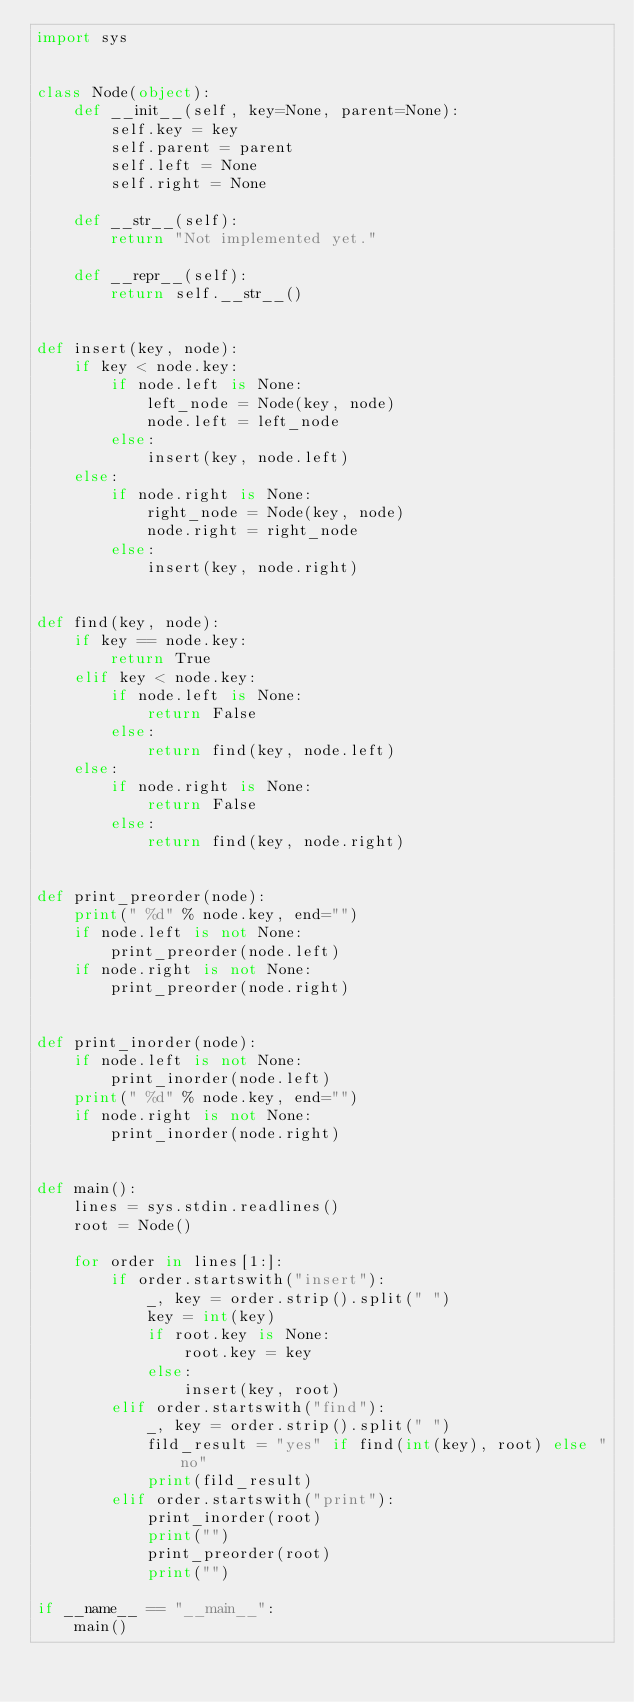Convert code to text. <code><loc_0><loc_0><loc_500><loc_500><_Python_>import sys


class Node(object):
    def __init__(self, key=None, parent=None):
        self.key = key
        self.parent = parent
        self.left = None
        self.right = None

    def __str__(self):
        return "Not implemented yet."

    def __repr__(self):
        return self.__str__()


def insert(key, node):
    if key < node.key:
        if node.left is None:
            left_node = Node(key, node)
            node.left = left_node
        else:
            insert(key, node.left)
    else:
        if node.right is None:
            right_node = Node(key, node)
            node.right = right_node
        else:
            insert(key, node.right)


def find(key, node):
    if key == node.key:
        return True
    elif key < node.key:
        if node.left is None:
            return False
        else:
            return find(key, node.left)
    else:
        if node.right is None:
            return False
        else:
            return find(key, node.right)


def print_preorder(node):
    print(" %d" % node.key, end="")
    if node.left is not None:
        print_preorder(node.left)
    if node.right is not None:
        print_preorder(node.right)


def print_inorder(node):
    if node.left is not None:
        print_inorder(node.left)
    print(" %d" % node.key, end="")
    if node.right is not None:
        print_inorder(node.right)


def main():
    lines = sys.stdin.readlines()
    root = Node()

    for order in lines[1:]:
        if order.startswith("insert"):
            _, key = order.strip().split(" ")
            key = int(key)
            if root.key is None:
                root.key = key
            else:
                insert(key, root)
        elif order.startswith("find"):
            _, key = order.strip().split(" ")
            fild_result = "yes" if find(int(key), root) else "no"
            print(fild_result)
        elif order.startswith("print"):
            print_inorder(root)
            print("")
            print_preorder(root)
            print("")

if __name__ == "__main__":
    main()</code> 